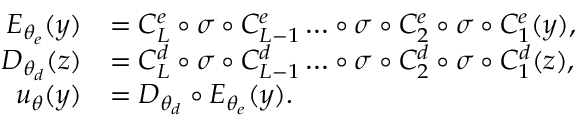Convert formula to latex. <formula><loc_0><loc_0><loc_500><loc_500>\begin{array} { r l } { E _ { \theta _ { e } } ( y ) } & { = C _ { L } ^ { e } \circ \sigma \circ C _ { L - 1 } ^ { e } \dots \circ \sigma \circ C _ { 2 } ^ { e } \circ \sigma \circ C _ { 1 } ^ { e } ( y ) , } \\ { D _ { \theta _ { d } } ( z ) } & { = C _ { L } ^ { d } \circ \sigma \circ C _ { L - 1 } ^ { d } \dots \circ \sigma \circ C _ { 2 } ^ { d } \circ \sigma \circ C _ { 1 } ^ { d } ( z ) , } \\ { u _ { \theta } ( y ) } & { = D _ { \theta _ { d } } \circ E _ { \theta _ { e } } ( y ) . } \end{array}</formula> 